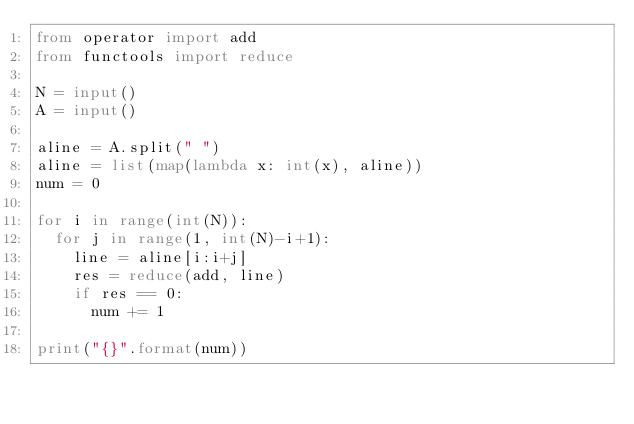<code> <loc_0><loc_0><loc_500><loc_500><_Python_>from operator import add
from functools import reduce

N = input()
A = input()

aline = A.split(" ")
aline = list(map(lambda x: int(x), aline))
num = 0

for i in range(int(N)):
  for j in range(1, int(N)-i+1):
    line = aline[i:i+j]
    res = reduce(add, line)
    if res == 0:
      num += 1

print("{}".format(num))</code> 